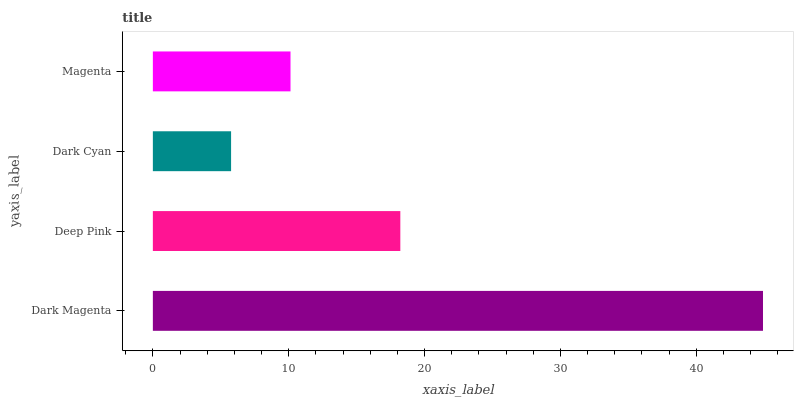Is Dark Cyan the minimum?
Answer yes or no. Yes. Is Dark Magenta the maximum?
Answer yes or no. Yes. Is Deep Pink the minimum?
Answer yes or no. No. Is Deep Pink the maximum?
Answer yes or no. No. Is Dark Magenta greater than Deep Pink?
Answer yes or no. Yes. Is Deep Pink less than Dark Magenta?
Answer yes or no. Yes. Is Deep Pink greater than Dark Magenta?
Answer yes or no. No. Is Dark Magenta less than Deep Pink?
Answer yes or no. No. Is Deep Pink the high median?
Answer yes or no. Yes. Is Magenta the low median?
Answer yes or no. Yes. Is Dark Magenta the high median?
Answer yes or no. No. Is Dark Magenta the low median?
Answer yes or no. No. 